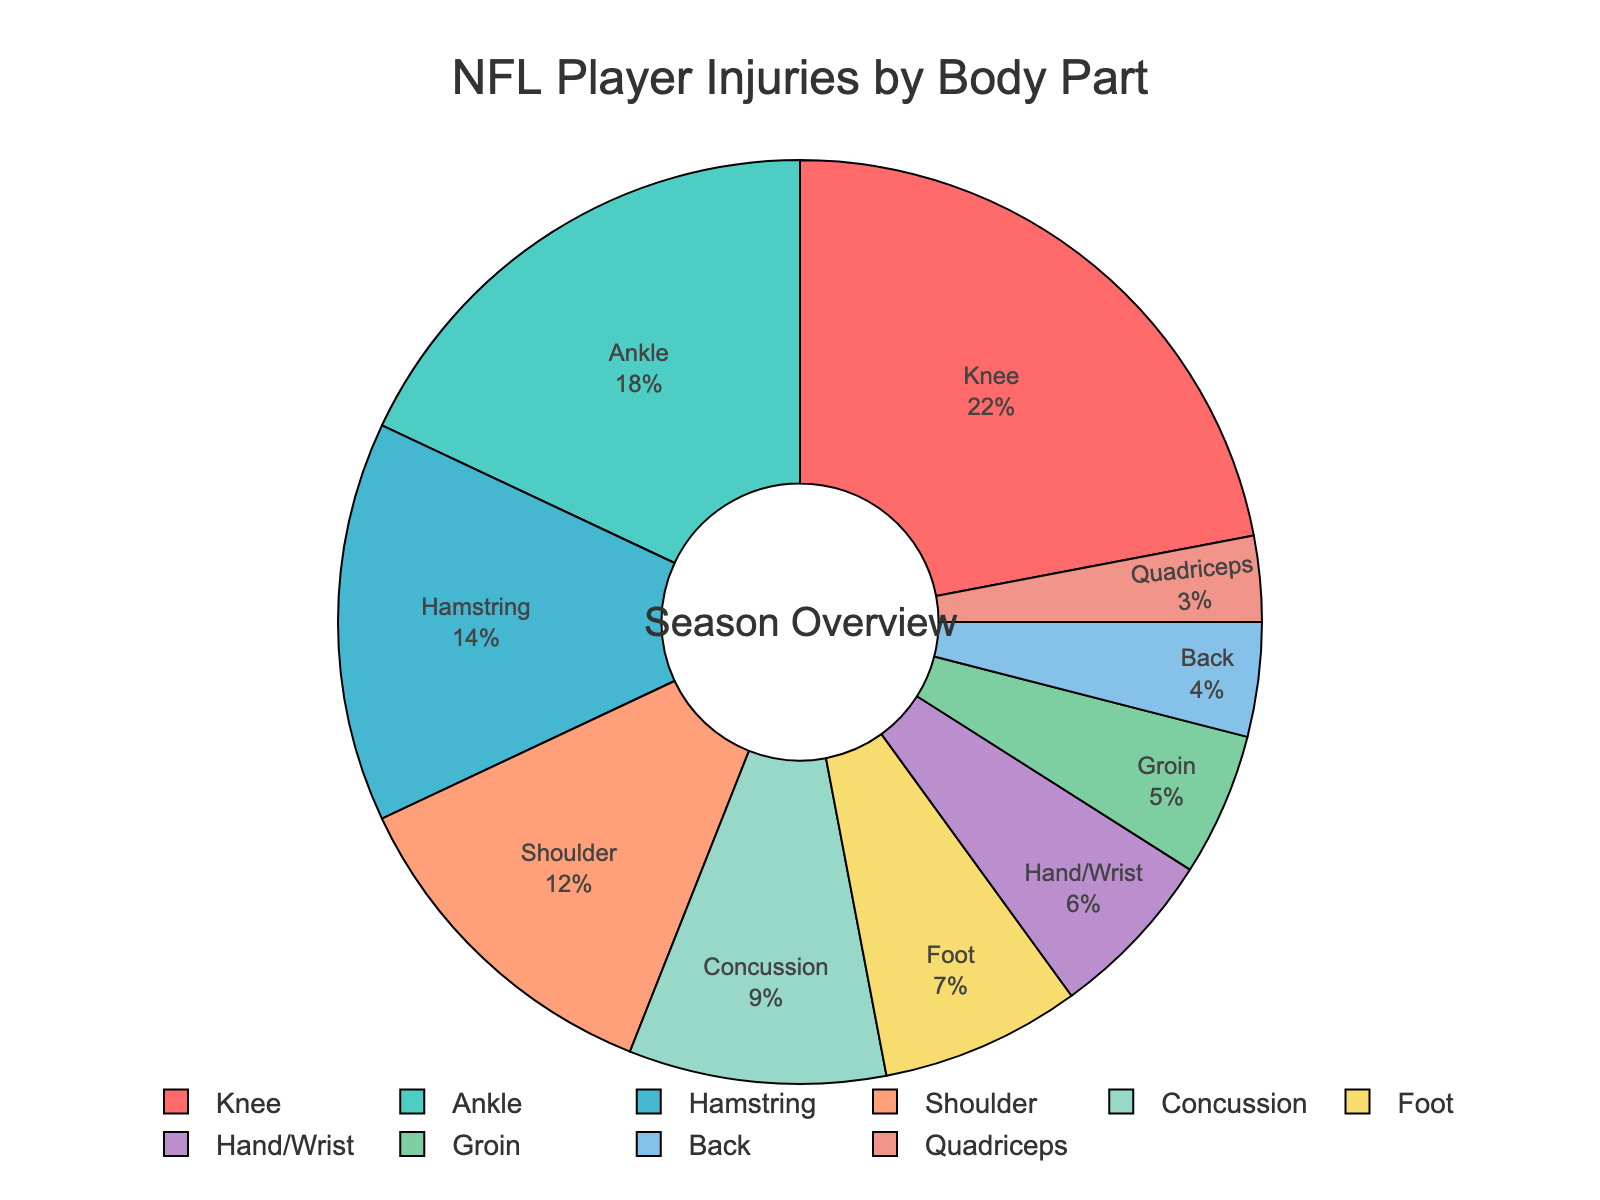Which body part has the highest percentage of injuries? The pie chart shows the percentage distribution of injuries among different body parts. The largest segment is labeled "Knee," with 22%.
Answer: Knee Which body parts have a combined injury percentage less than 10%? Summing the percentages of smaller segments helps answer this. From the chart: Back (4%), Quadriceps (3%), and Groin (5%), but Groin exceeds the 10% threshold when added to the others.
Answer: Back, Quadriceps How much higher is the percentage of knee injuries compared to hamstring injuries? The percentages of knee and hamstring injuries are 22% and 14%, respectively. The difference is 22% - 14%.
Answer: 8% What is the total percentage of injuries related to the leg (Knee, Ankle, Hamstring, Foot, Quadriceps)? Add the percentages for Knee (22%), Ankle (18%), Hamstring (14%), Foot (7%), and Quadriceps (3%) for a total. The sum is 22 + 18 + 14 + 7 + 3.
Answer: 64% Rank the top three most frequently injured body parts. By examining the chart, the top three injury percentages are Knee (22%), Ankle (18%), and Hamstring (14%).
Answer: Knee, Ankle, Hamstring What is the percentage difference between shoulder and back injuries? The chart gives shoulder injuries at 12% and back injuries at 4%. The difference is 12% - 4%.
Answer: 8% Which body parts have injury percentages in single digits? Single-digit percentages in the chart are Concussion (9%), Foot (7%), Hand/Wrist (6%), Groin (5%), Back (4%), and Quadriceps (3%).
Answer: Concussion, Foot, Hand/Wrist, Groin, Back, Quadriceps If you combine the injuries of Hand/Wrist and Groin, how do they compare to Shoulder injuries? Add Hand/Wrist (6%) and Groin (5%) injuries. The combined percentage is 6% + 5%, which is 11% compared to Shoulder’s 12%.
Answer: Less than What is the difference in injury percentage between the most and least injured body parts? The highest is Knee (22%), and the lowest is Quadriceps (3%). The difference is 22% - 3%.
Answer: 19% How do the percentages of concussion injuries compare to foot injuries? The chart lists Concussion injuries at 9% and Foot injuries at 7%. Concussion injuries are more.
Answer: More 